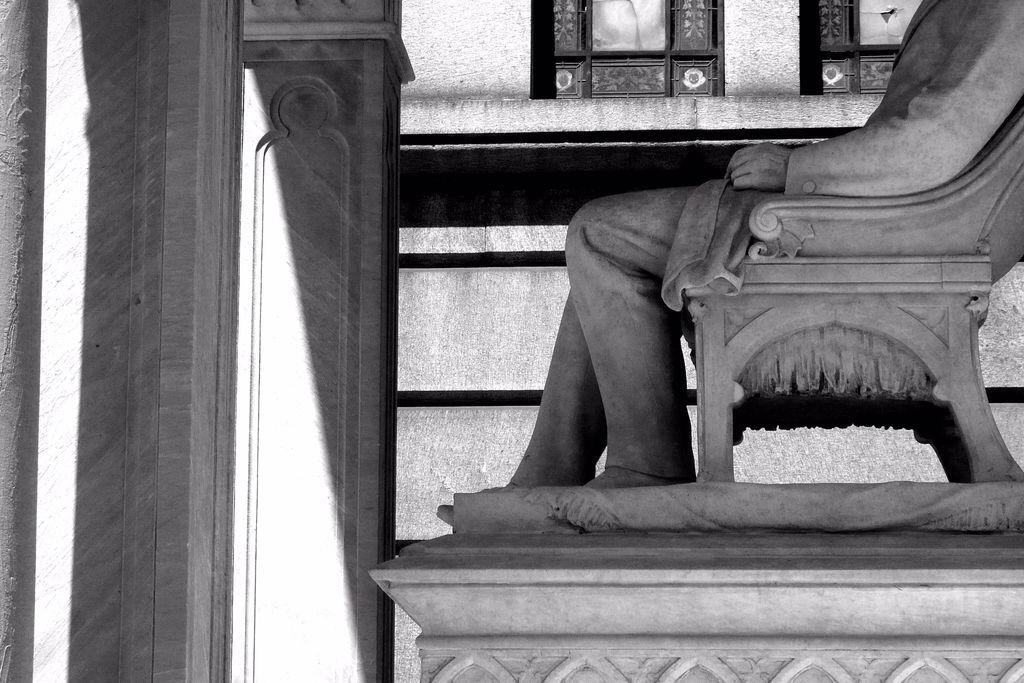What is the main subject of the image? There is a statue of a person in the image. What is the statue doing in the image? The statue is sitting on a chair. What can be seen in the background of the image? There is a wall in the background of the image. What type of salt is sprinkled on the vegetable in the image? There is no salt or vegetable present in the image; it features a statue sitting on a chair with a wall in the background. 